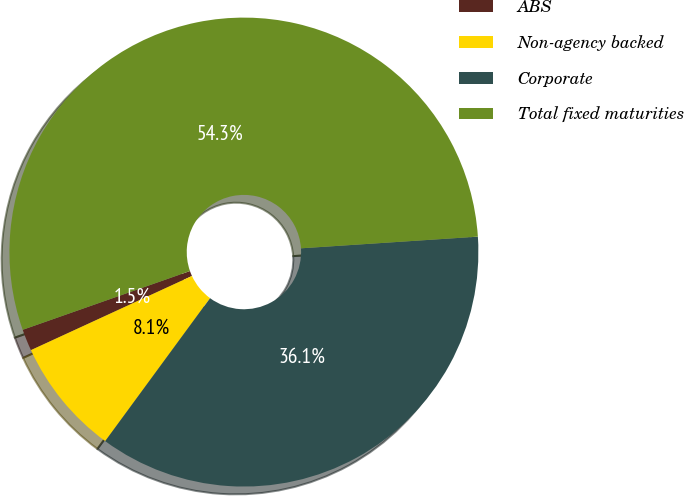<chart> <loc_0><loc_0><loc_500><loc_500><pie_chart><fcel>ABS<fcel>Non-agency backed<fcel>Corporate<fcel>Total fixed maturities<nl><fcel>1.49%<fcel>8.06%<fcel>36.12%<fcel>54.33%<nl></chart> 